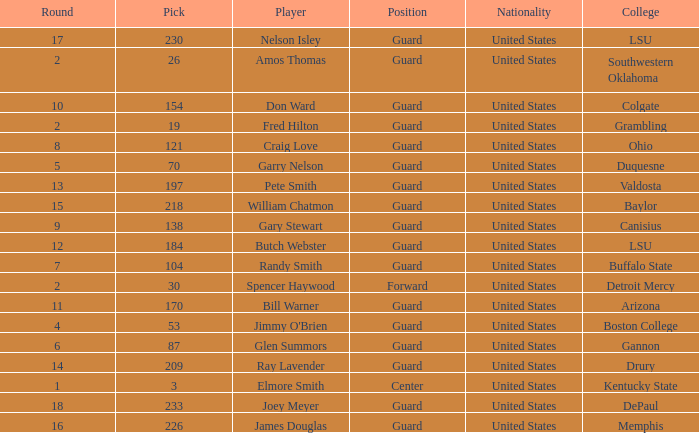WHAT IS THE TOTAL PICK FOR BOSTON COLLEGE? 1.0. 